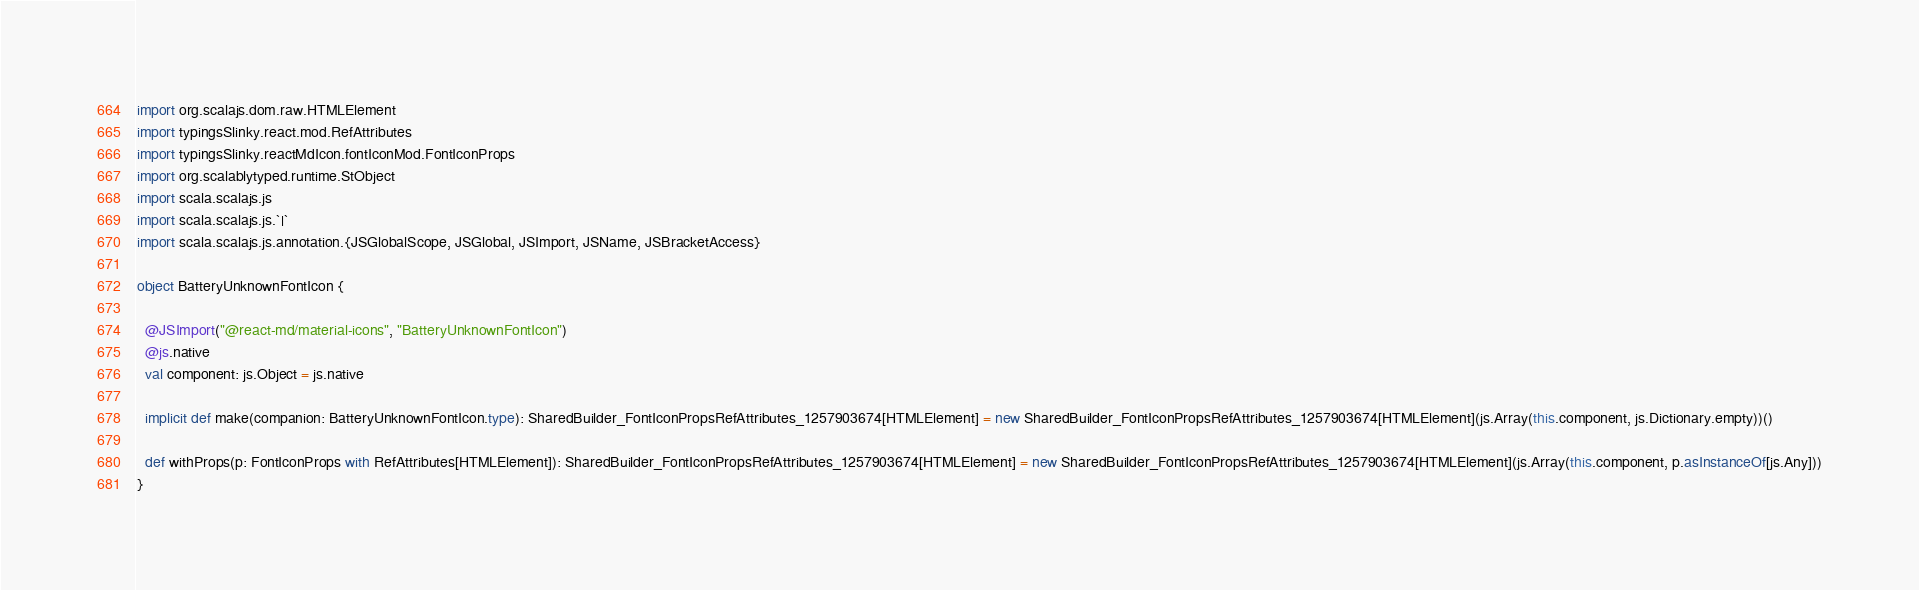Convert code to text. <code><loc_0><loc_0><loc_500><loc_500><_Scala_>
import org.scalajs.dom.raw.HTMLElement
import typingsSlinky.react.mod.RefAttributes
import typingsSlinky.reactMdIcon.fontIconMod.FontIconProps
import org.scalablytyped.runtime.StObject
import scala.scalajs.js
import scala.scalajs.js.`|`
import scala.scalajs.js.annotation.{JSGlobalScope, JSGlobal, JSImport, JSName, JSBracketAccess}

object BatteryUnknownFontIcon {
  
  @JSImport("@react-md/material-icons", "BatteryUnknownFontIcon")
  @js.native
  val component: js.Object = js.native
  
  implicit def make(companion: BatteryUnknownFontIcon.type): SharedBuilder_FontIconPropsRefAttributes_1257903674[HTMLElement] = new SharedBuilder_FontIconPropsRefAttributes_1257903674[HTMLElement](js.Array(this.component, js.Dictionary.empty))()
  
  def withProps(p: FontIconProps with RefAttributes[HTMLElement]): SharedBuilder_FontIconPropsRefAttributes_1257903674[HTMLElement] = new SharedBuilder_FontIconPropsRefAttributes_1257903674[HTMLElement](js.Array(this.component, p.asInstanceOf[js.Any]))
}
</code> 